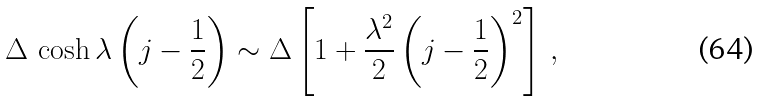<formula> <loc_0><loc_0><loc_500><loc_500>\Delta \, \cosh \lambda \left ( j - { \frac { 1 } { 2 } } \right ) \sim \Delta \left [ 1 + \frac { \lambda ^ { 2 } } { 2 } \left ( j - { \frac { 1 } { 2 } } \right ) ^ { 2 } \right ] \, ,</formula> 